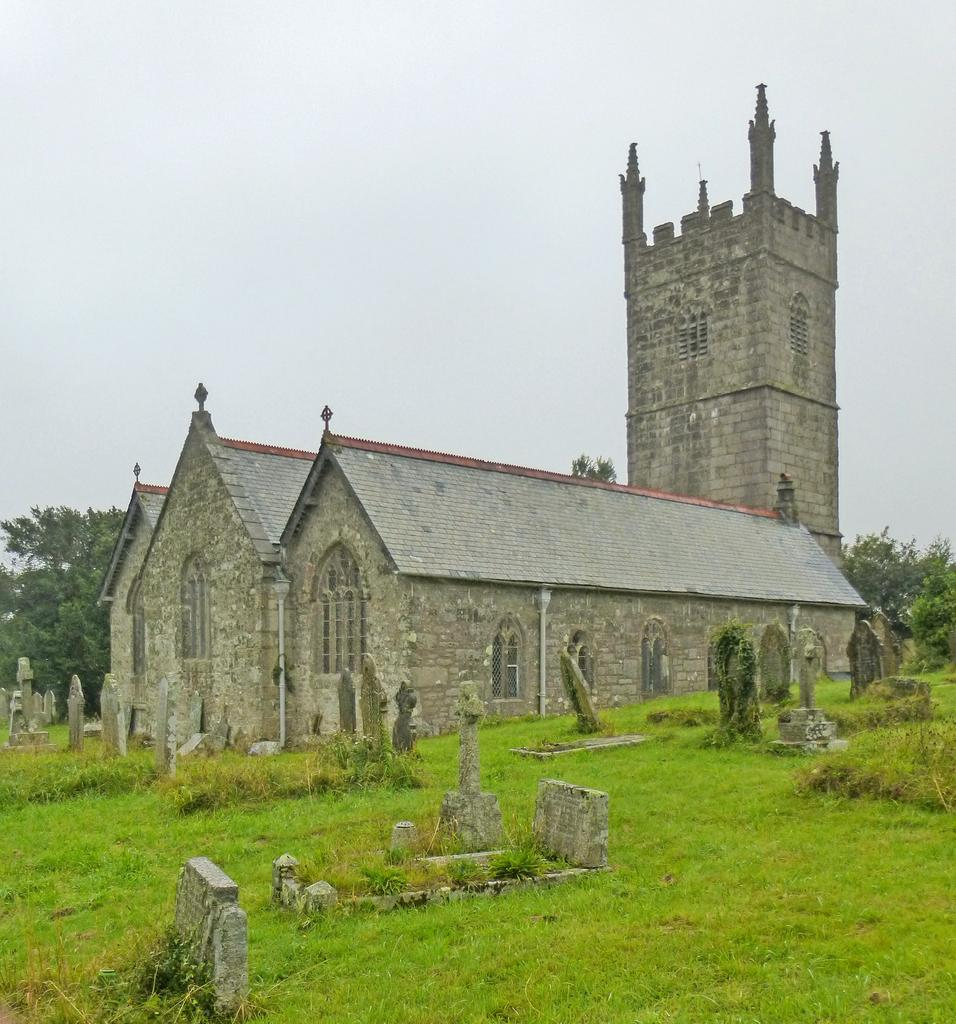What is the main structure in the middle of the image? There is a building in the middle of the image. What type of vegetation can be seen on the left side of the image? There are trees on the left side of the image. What type of vegetation can be seen on the right side of the image? There are trees on the right side of the image. What type of ground surface is visible at the bottom of the image? There is grass at the bottom of the image. What part of the natural environment is visible at the top of the image? The sky is visible at the top of the image. Where is the lunchroom located in the image? There is no lunchroom present in the image. How many ants can be seen crawling on the building in the image? There are no ants visible in the image. 